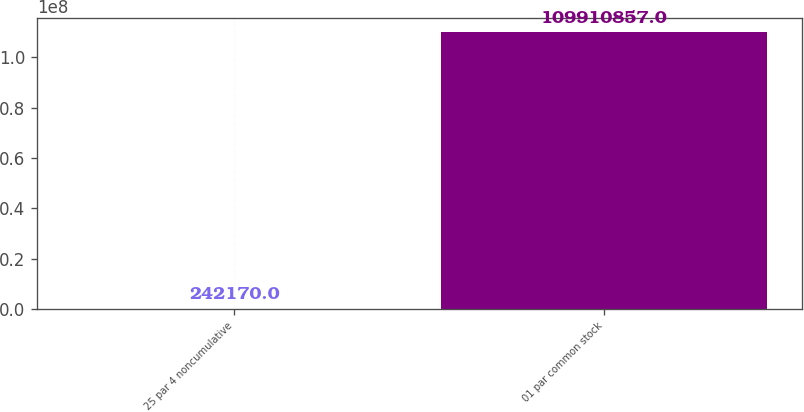<chart> <loc_0><loc_0><loc_500><loc_500><bar_chart><fcel>25 par 4 noncumulative<fcel>01 par common stock<nl><fcel>242170<fcel>1.09911e+08<nl></chart> 